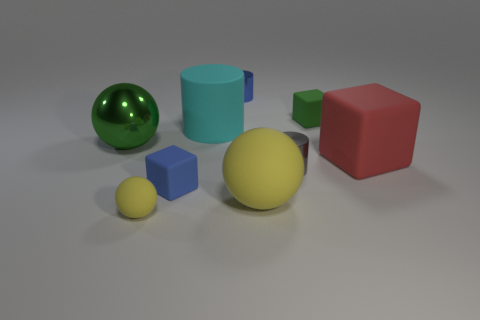Do the cylinder in front of the large red matte thing and the large metal sphere have the same color?
Provide a succinct answer. No. Do the blue thing that is right of the tiny blue matte cube and the yellow sphere that is right of the small blue metallic cylinder have the same size?
Offer a very short reply. No. The cyan thing that is made of the same material as the small green object is what size?
Your response must be concise. Large. How many rubber things are both in front of the blue matte cube and to the right of the small yellow thing?
Keep it short and to the point. 1. How many things are either blue objects or metallic objects that are on the right side of the cyan matte thing?
Your answer should be compact. 3. The other object that is the same color as the big shiny object is what shape?
Ensure brevity in your answer.  Cube. There is a big sphere that is right of the small matte ball; what color is it?
Provide a succinct answer. Yellow. What number of objects are either balls right of the big green thing or shiny cylinders?
Provide a succinct answer. 4. There is a cylinder that is the same size as the green shiny ball; what color is it?
Ensure brevity in your answer.  Cyan. Are there more cylinders that are behind the green ball than small metallic balls?
Offer a terse response. Yes. 